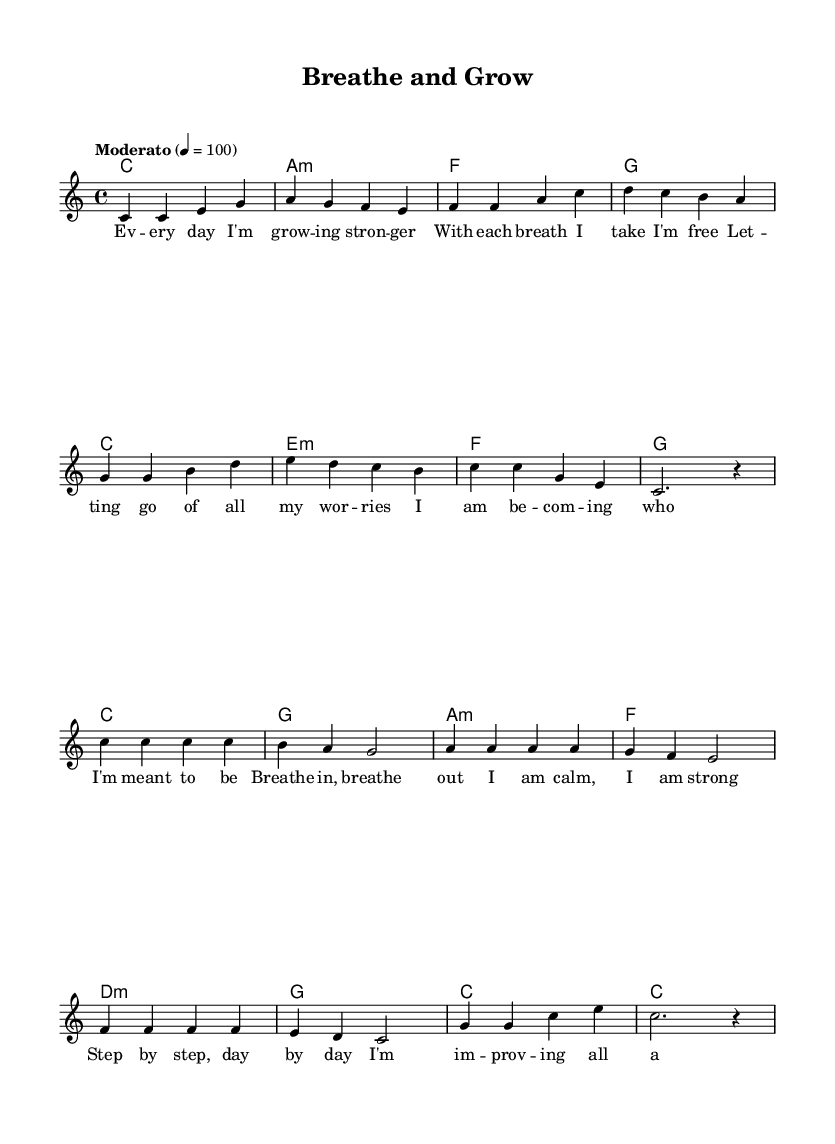What is the key signature of this music? The key signature is C major, which has no sharps or flats, indicated at the beginning of the sheet music.
Answer: C major What is the time signature? The time signature is 4/4, shown at the beginning of the score, indicating there are four beats in each measure.
Answer: 4/4 What is the tempo marking for this piece? The tempo marking is "Moderato," specified in the tempo section, which means a moderate speed. The number "100" indicates the beats per minute.
Answer: Moderato How many measures does the chorus section have? To find the number of measures in the chorus, count the measures in the chorus section, which includes eight unique measures.
Answer: 8 What are the first four words of the lyrics in the verse? The first four words of the verse can be found by reading the lyrics starting from the beginning: "Every day I'm growing."
Answer: Every day I'm growing What chord follows the first measure of the chorus? The first measure of the chorus contains the note C, which corresponds to the chord indicated in the chord section right after the first measure.
Answer: G What is the mood of the song based on its lyrics and musical composition? The lyrics express themes of growth and positivity, suggesting an overall uplifting and motivational mood, supported by the lively melody and harmony.
Answer: Uplifting 